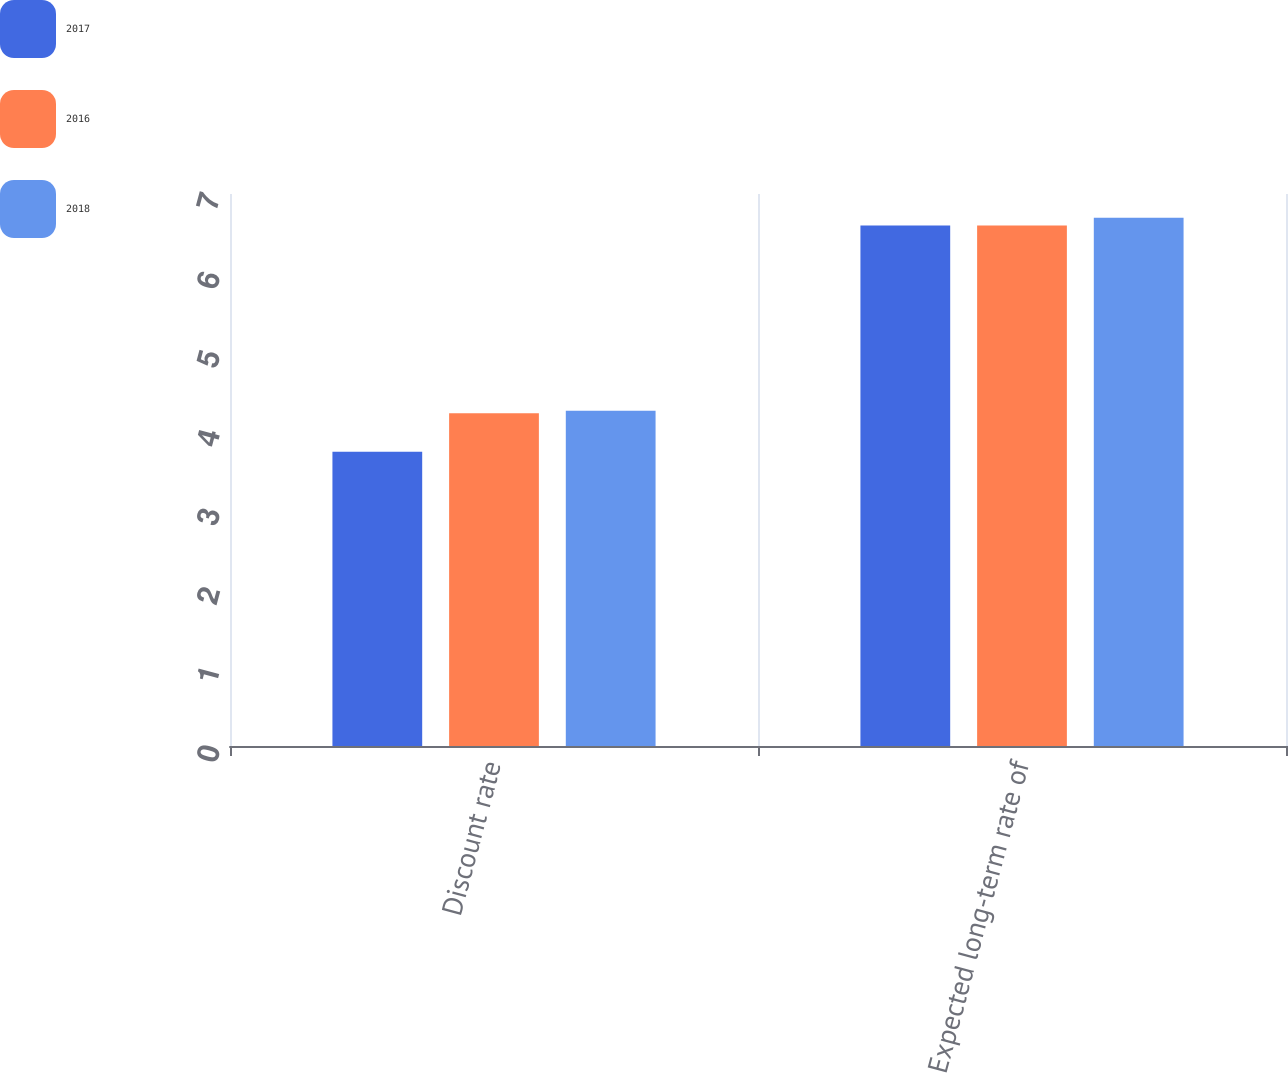Convert chart to OTSL. <chart><loc_0><loc_0><loc_500><loc_500><stacked_bar_chart><ecel><fcel>Discount rate<fcel>Expected long-term rate of<nl><fcel>2017<fcel>3.73<fcel>6.6<nl><fcel>2016<fcel>4.22<fcel>6.6<nl><fcel>2018<fcel>4.25<fcel>6.7<nl></chart> 